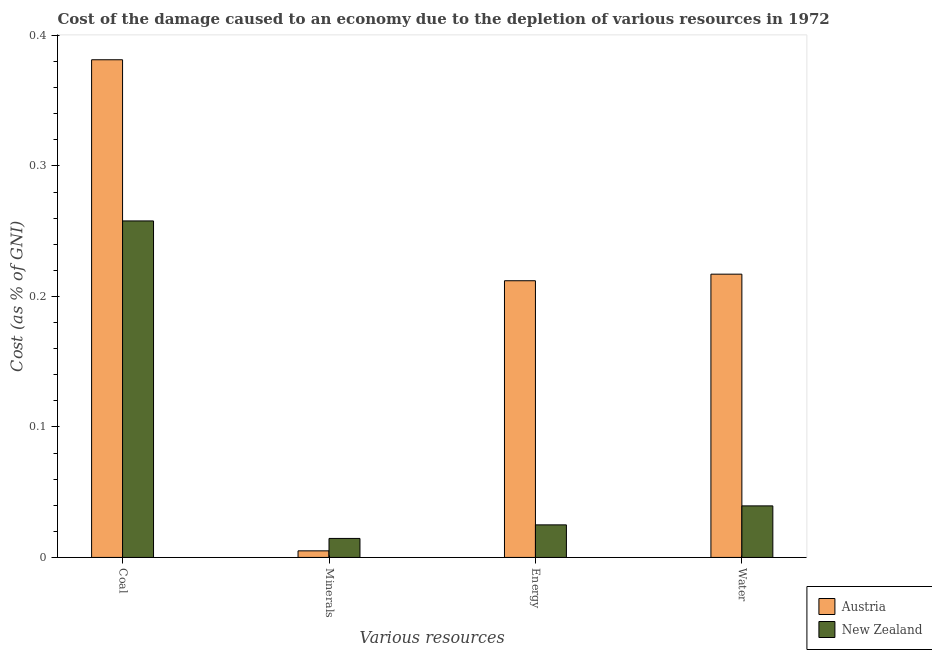How many different coloured bars are there?
Keep it short and to the point. 2. Are the number of bars per tick equal to the number of legend labels?
Provide a short and direct response. Yes. Are the number of bars on each tick of the X-axis equal?
Your answer should be compact. Yes. How many bars are there on the 2nd tick from the left?
Keep it short and to the point. 2. How many bars are there on the 3rd tick from the right?
Ensure brevity in your answer.  2. What is the label of the 1st group of bars from the left?
Provide a short and direct response. Coal. What is the cost of damage due to depletion of coal in Austria?
Provide a short and direct response. 0.38. Across all countries, what is the maximum cost of damage due to depletion of energy?
Your answer should be very brief. 0.21. Across all countries, what is the minimum cost of damage due to depletion of minerals?
Provide a succinct answer. 0.01. In which country was the cost of damage due to depletion of coal maximum?
Provide a succinct answer. Austria. In which country was the cost of damage due to depletion of water minimum?
Your response must be concise. New Zealand. What is the total cost of damage due to depletion of coal in the graph?
Your answer should be compact. 0.64. What is the difference between the cost of damage due to depletion of energy in Austria and that in New Zealand?
Offer a terse response. 0.19. What is the difference between the cost of damage due to depletion of water in Austria and the cost of damage due to depletion of coal in New Zealand?
Provide a short and direct response. -0.04. What is the average cost of damage due to depletion of water per country?
Your answer should be compact. 0.13. What is the difference between the cost of damage due to depletion of water and cost of damage due to depletion of minerals in Austria?
Ensure brevity in your answer.  0.21. In how many countries, is the cost of damage due to depletion of coal greater than 0.18 %?
Your answer should be compact. 2. What is the ratio of the cost of damage due to depletion of coal in Austria to that in New Zealand?
Give a very brief answer. 1.48. Is the cost of damage due to depletion of coal in New Zealand less than that in Austria?
Your answer should be compact. Yes. Is the difference between the cost of damage due to depletion of minerals in Austria and New Zealand greater than the difference between the cost of damage due to depletion of coal in Austria and New Zealand?
Give a very brief answer. No. What is the difference between the highest and the second highest cost of damage due to depletion of water?
Keep it short and to the point. 0.18. What is the difference between the highest and the lowest cost of damage due to depletion of coal?
Keep it short and to the point. 0.12. In how many countries, is the cost of damage due to depletion of coal greater than the average cost of damage due to depletion of coal taken over all countries?
Offer a very short reply. 1. Is it the case that in every country, the sum of the cost of damage due to depletion of minerals and cost of damage due to depletion of water is greater than the sum of cost of damage due to depletion of coal and cost of damage due to depletion of energy?
Make the answer very short. No. What does the 2nd bar from the left in Coal represents?
Offer a very short reply. New Zealand. How many bars are there?
Your response must be concise. 8. How many countries are there in the graph?
Your answer should be very brief. 2. Are the values on the major ticks of Y-axis written in scientific E-notation?
Offer a terse response. No. Where does the legend appear in the graph?
Ensure brevity in your answer.  Bottom right. How many legend labels are there?
Offer a very short reply. 2. What is the title of the graph?
Keep it short and to the point. Cost of the damage caused to an economy due to the depletion of various resources in 1972 . Does "Belgium" appear as one of the legend labels in the graph?
Give a very brief answer. No. What is the label or title of the X-axis?
Your answer should be compact. Various resources. What is the label or title of the Y-axis?
Your answer should be very brief. Cost (as % of GNI). What is the Cost (as % of GNI) in Austria in Coal?
Your response must be concise. 0.38. What is the Cost (as % of GNI) in New Zealand in Coal?
Offer a very short reply. 0.26. What is the Cost (as % of GNI) in Austria in Minerals?
Provide a short and direct response. 0.01. What is the Cost (as % of GNI) in New Zealand in Minerals?
Give a very brief answer. 0.01. What is the Cost (as % of GNI) in Austria in Energy?
Ensure brevity in your answer.  0.21. What is the Cost (as % of GNI) of New Zealand in Energy?
Your response must be concise. 0.02. What is the Cost (as % of GNI) in Austria in Water?
Give a very brief answer. 0.22. What is the Cost (as % of GNI) of New Zealand in Water?
Your answer should be very brief. 0.04. Across all Various resources, what is the maximum Cost (as % of GNI) of Austria?
Keep it short and to the point. 0.38. Across all Various resources, what is the maximum Cost (as % of GNI) in New Zealand?
Your response must be concise. 0.26. Across all Various resources, what is the minimum Cost (as % of GNI) in Austria?
Offer a terse response. 0.01. Across all Various resources, what is the minimum Cost (as % of GNI) of New Zealand?
Make the answer very short. 0.01. What is the total Cost (as % of GNI) in Austria in the graph?
Keep it short and to the point. 0.82. What is the total Cost (as % of GNI) of New Zealand in the graph?
Your response must be concise. 0.34. What is the difference between the Cost (as % of GNI) of Austria in Coal and that in Minerals?
Make the answer very short. 0.38. What is the difference between the Cost (as % of GNI) in New Zealand in Coal and that in Minerals?
Your response must be concise. 0.24. What is the difference between the Cost (as % of GNI) in Austria in Coal and that in Energy?
Give a very brief answer. 0.17. What is the difference between the Cost (as % of GNI) of New Zealand in Coal and that in Energy?
Ensure brevity in your answer.  0.23. What is the difference between the Cost (as % of GNI) of Austria in Coal and that in Water?
Provide a succinct answer. 0.16. What is the difference between the Cost (as % of GNI) of New Zealand in Coal and that in Water?
Keep it short and to the point. 0.22. What is the difference between the Cost (as % of GNI) in Austria in Minerals and that in Energy?
Your response must be concise. -0.21. What is the difference between the Cost (as % of GNI) of New Zealand in Minerals and that in Energy?
Offer a very short reply. -0.01. What is the difference between the Cost (as % of GNI) in Austria in Minerals and that in Water?
Ensure brevity in your answer.  -0.21. What is the difference between the Cost (as % of GNI) of New Zealand in Minerals and that in Water?
Make the answer very short. -0.02. What is the difference between the Cost (as % of GNI) of Austria in Energy and that in Water?
Provide a short and direct response. -0.01. What is the difference between the Cost (as % of GNI) in New Zealand in Energy and that in Water?
Provide a succinct answer. -0.01. What is the difference between the Cost (as % of GNI) of Austria in Coal and the Cost (as % of GNI) of New Zealand in Minerals?
Keep it short and to the point. 0.37. What is the difference between the Cost (as % of GNI) of Austria in Coal and the Cost (as % of GNI) of New Zealand in Energy?
Make the answer very short. 0.36. What is the difference between the Cost (as % of GNI) of Austria in Coal and the Cost (as % of GNI) of New Zealand in Water?
Your response must be concise. 0.34. What is the difference between the Cost (as % of GNI) of Austria in Minerals and the Cost (as % of GNI) of New Zealand in Energy?
Offer a terse response. -0.02. What is the difference between the Cost (as % of GNI) in Austria in Minerals and the Cost (as % of GNI) in New Zealand in Water?
Your answer should be compact. -0.03. What is the difference between the Cost (as % of GNI) of Austria in Energy and the Cost (as % of GNI) of New Zealand in Water?
Keep it short and to the point. 0.17. What is the average Cost (as % of GNI) of Austria per Various resources?
Offer a terse response. 0.2. What is the average Cost (as % of GNI) of New Zealand per Various resources?
Provide a succinct answer. 0.08. What is the difference between the Cost (as % of GNI) in Austria and Cost (as % of GNI) in New Zealand in Coal?
Give a very brief answer. 0.12. What is the difference between the Cost (as % of GNI) of Austria and Cost (as % of GNI) of New Zealand in Minerals?
Offer a terse response. -0.01. What is the difference between the Cost (as % of GNI) of Austria and Cost (as % of GNI) of New Zealand in Energy?
Offer a very short reply. 0.19. What is the difference between the Cost (as % of GNI) of Austria and Cost (as % of GNI) of New Zealand in Water?
Your answer should be very brief. 0.18. What is the ratio of the Cost (as % of GNI) of Austria in Coal to that in Minerals?
Offer a very short reply. 75.65. What is the ratio of the Cost (as % of GNI) in New Zealand in Coal to that in Minerals?
Your response must be concise. 17.72. What is the ratio of the Cost (as % of GNI) in Austria in Coal to that in Energy?
Your answer should be compact. 1.8. What is the ratio of the Cost (as % of GNI) of New Zealand in Coal to that in Energy?
Your response must be concise. 10.34. What is the ratio of the Cost (as % of GNI) in Austria in Coal to that in Water?
Your answer should be very brief. 1.76. What is the ratio of the Cost (as % of GNI) in New Zealand in Coal to that in Water?
Keep it short and to the point. 6.53. What is the ratio of the Cost (as % of GNI) in Austria in Minerals to that in Energy?
Provide a short and direct response. 0.02. What is the ratio of the Cost (as % of GNI) of New Zealand in Minerals to that in Energy?
Keep it short and to the point. 0.58. What is the ratio of the Cost (as % of GNI) in Austria in Minerals to that in Water?
Ensure brevity in your answer.  0.02. What is the ratio of the Cost (as % of GNI) in New Zealand in Minerals to that in Water?
Offer a very short reply. 0.37. What is the ratio of the Cost (as % of GNI) of Austria in Energy to that in Water?
Your answer should be very brief. 0.98. What is the ratio of the Cost (as % of GNI) in New Zealand in Energy to that in Water?
Your answer should be compact. 0.63. What is the difference between the highest and the second highest Cost (as % of GNI) in Austria?
Provide a succinct answer. 0.16. What is the difference between the highest and the second highest Cost (as % of GNI) in New Zealand?
Ensure brevity in your answer.  0.22. What is the difference between the highest and the lowest Cost (as % of GNI) in Austria?
Keep it short and to the point. 0.38. What is the difference between the highest and the lowest Cost (as % of GNI) of New Zealand?
Your answer should be compact. 0.24. 